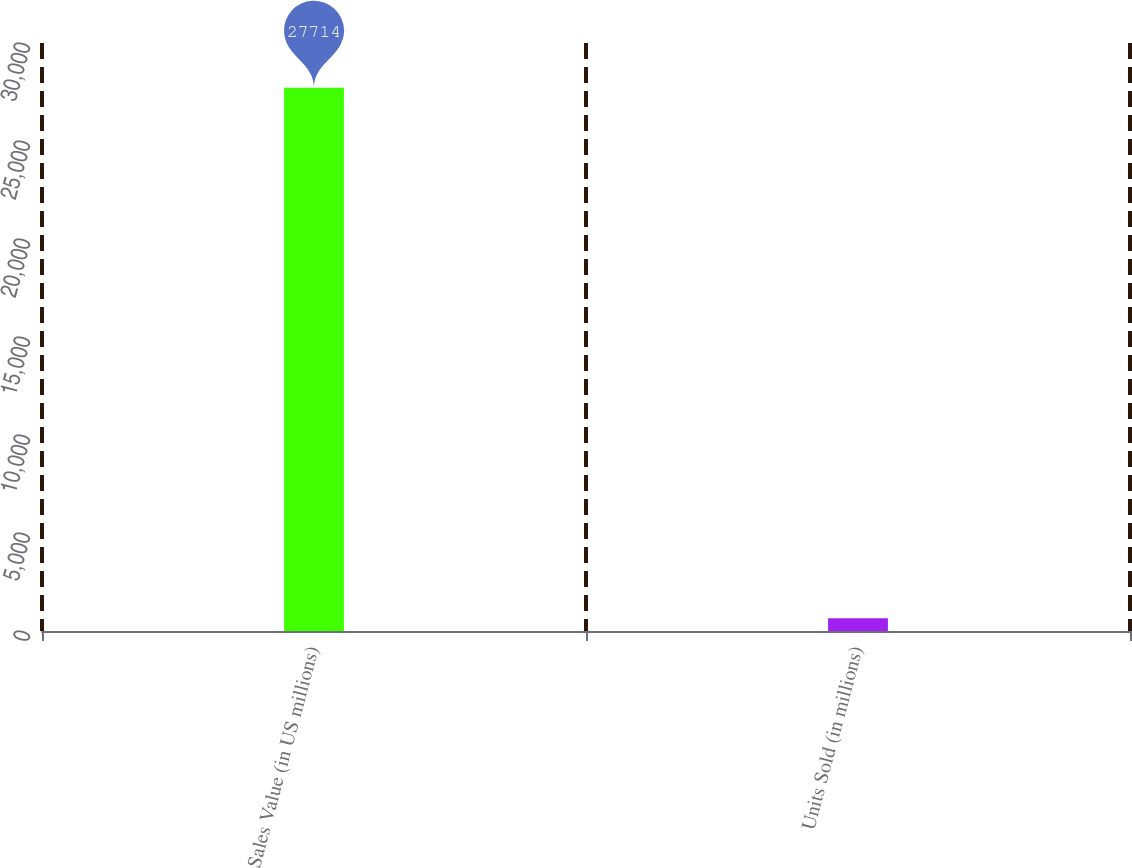Convert chart. <chart><loc_0><loc_0><loc_500><loc_500><bar_chart><fcel>Sales Value (in US millions)<fcel>Units Sold (in millions)<nl><fcel>27714<fcel>645.5<nl></chart> 